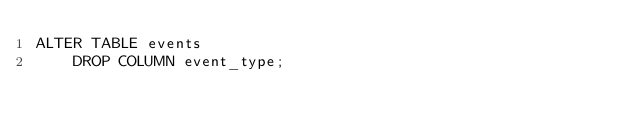Convert code to text. <code><loc_0><loc_0><loc_500><loc_500><_SQL_>ALTER TABLE events
    DROP COLUMN event_type;</code> 